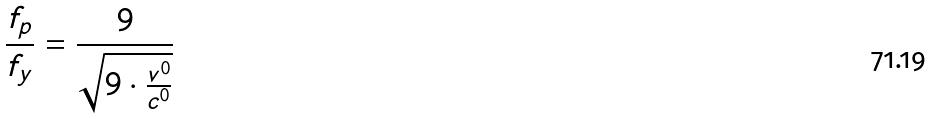Convert formula to latex. <formula><loc_0><loc_0><loc_500><loc_500>\frac { f _ { p } } { f _ { y } } = \frac { 9 } { \sqrt { 9 \cdot \frac { v ^ { 0 } } { c ^ { 0 } } } }</formula> 